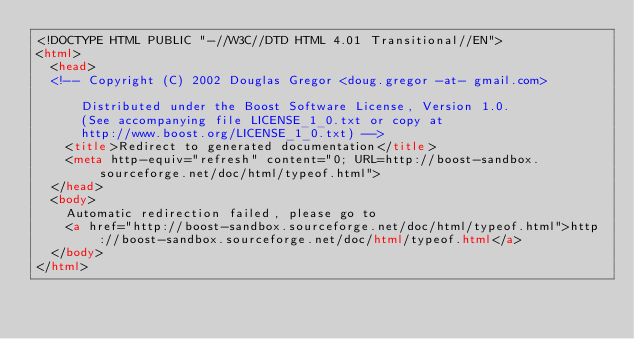<code> <loc_0><loc_0><loc_500><loc_500><_HTML_><!DOCTYPE HTML PUBLIC "-//W3C//DTD HTML 4.01 Transitional//EN">
<html>
  <head>
  <!-- Copyright (C) 2002 Douglas Gregor <doug.gregor -at- gmail.com>

      Distributed under the Boost Software License, Version 1.0.
      (See accompanying file LICENSE_1_0.txt or copy at
      http://www.boost.org/LICENSE_1_0.txt) -->
    <title>Redirect to generated documentation</title>
    <meta http-equiv="refresh" content="0; URL=http://boost-sandbox.sourceforge.net/doc/html/typeof.html">
  </head>
  <body>
    Automatic redirection failed, please go to
    <a href="http://boost-sandbox.sourceforge.net/doc/html/typeof.html">http://boost-sandbox.sourceforge.net/doc/html/typeof.html</a>
  </body>
</html>
</code> 